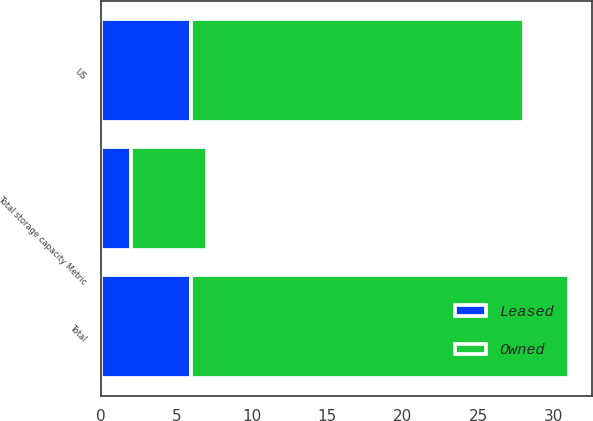<chart> <loc_0><loc_0><loc_500><loc_500><stacked_bar_chart><ecel><fcel>US<fcel>Total<fcel>Total storage capacity Metric<nl><fcel>Owned<fcel>22<fcel>25<fcel>5<nl><fcel>Leased<fcel>6<fcel>6<fcel>2<nl></chart> 